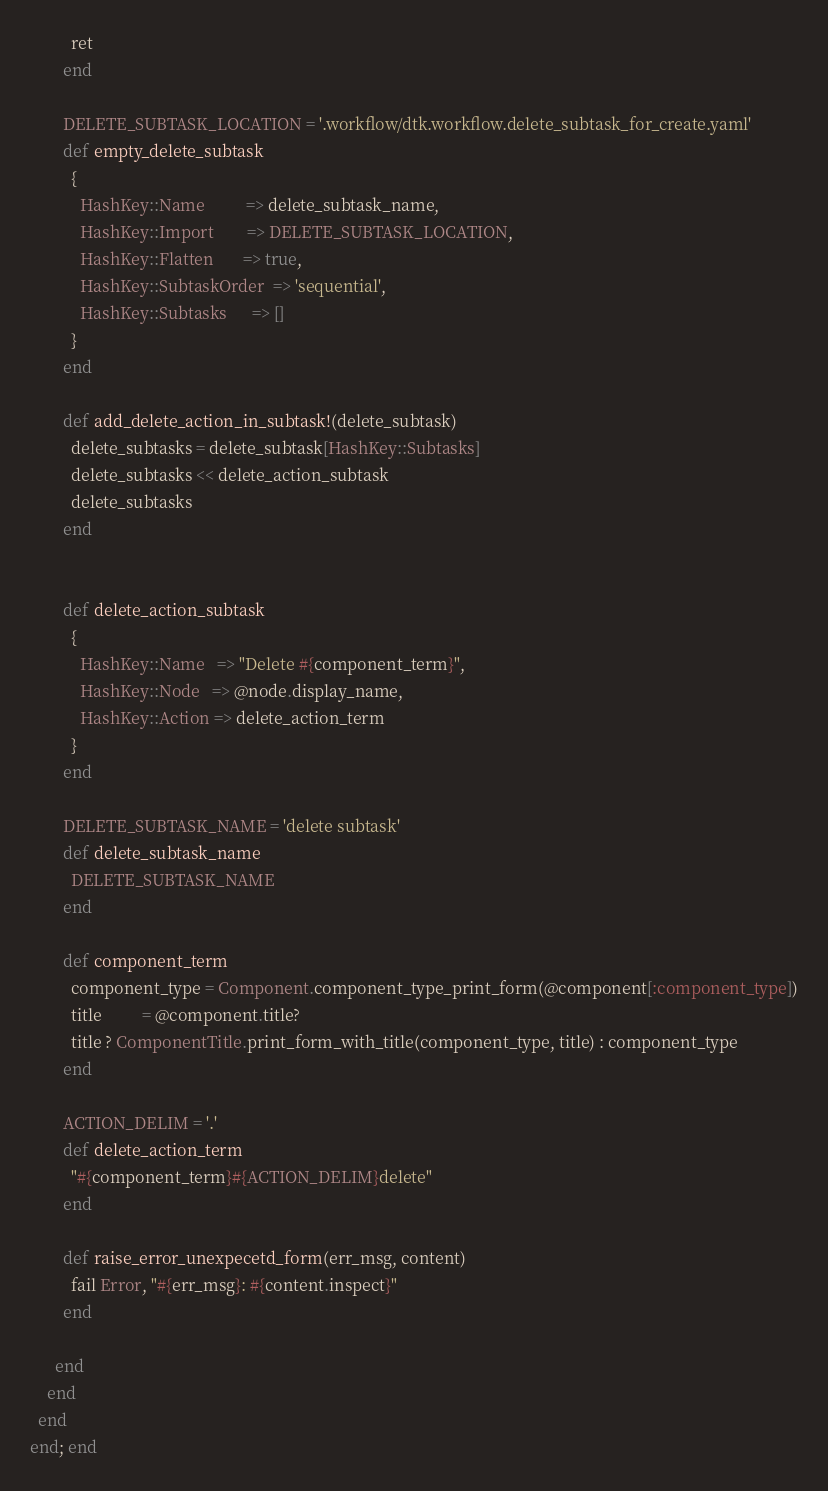<code> <loc_0><loc_0><loc_500><loc_500><_Ruby_>
          ret
        end

        DELETE_SUBTASK_LOCATION = '.workflow/dtk.workflow.delete_subtask_for_create.yaml'
        def empty_delete_subtask
          {
            HashKey::Name          => delete_subtask_name,
            HashKey::Import        => DELETE_SUBTASK_LOCATION,
            HashKey::Flatten       => true,
            HashKey::SubtaskOrder  => 'sequential',
            HashKey::Subtasks      => []
          }
        end

        def add_delete_action_in_subtask!(delete_subtask)
          delete_subtasks = delete_subtask[HashKey::Subtasks]
          delete_subtasks << delete_action_subtask
          delete_subtasks
        end

        
        def delete_action_subtask
          { 
            HashKey::Name   => "Delete #{component_term}",
            HashKey::Node   => @node.display_name,
            HashKey::Action => delete_action_term 
          } 
        end

        DELETE_SUBTASK_NAME = 'delete subtask'
        def delete_subtask_name
          DELETE_SUBTASK_NAME
        end

        def component_term
          component_type = Component.component_type_print_form(@component[:component_type])
          title          = @component.title?
          title ? ComponentTitle.print_form_with_title(component_type, title) : component_type
        end

        ACTION_DELIM = '.'
        def delete_action_term
          "#{component_term}#{ACTION_DELIM}delete"
        end

        def raise_error_unexpecetd_form(err_msg, content)
          fail Error, "#{err_msg}: #{content.inspect}"
        end

      end
    end
  end
end; end
</code> 